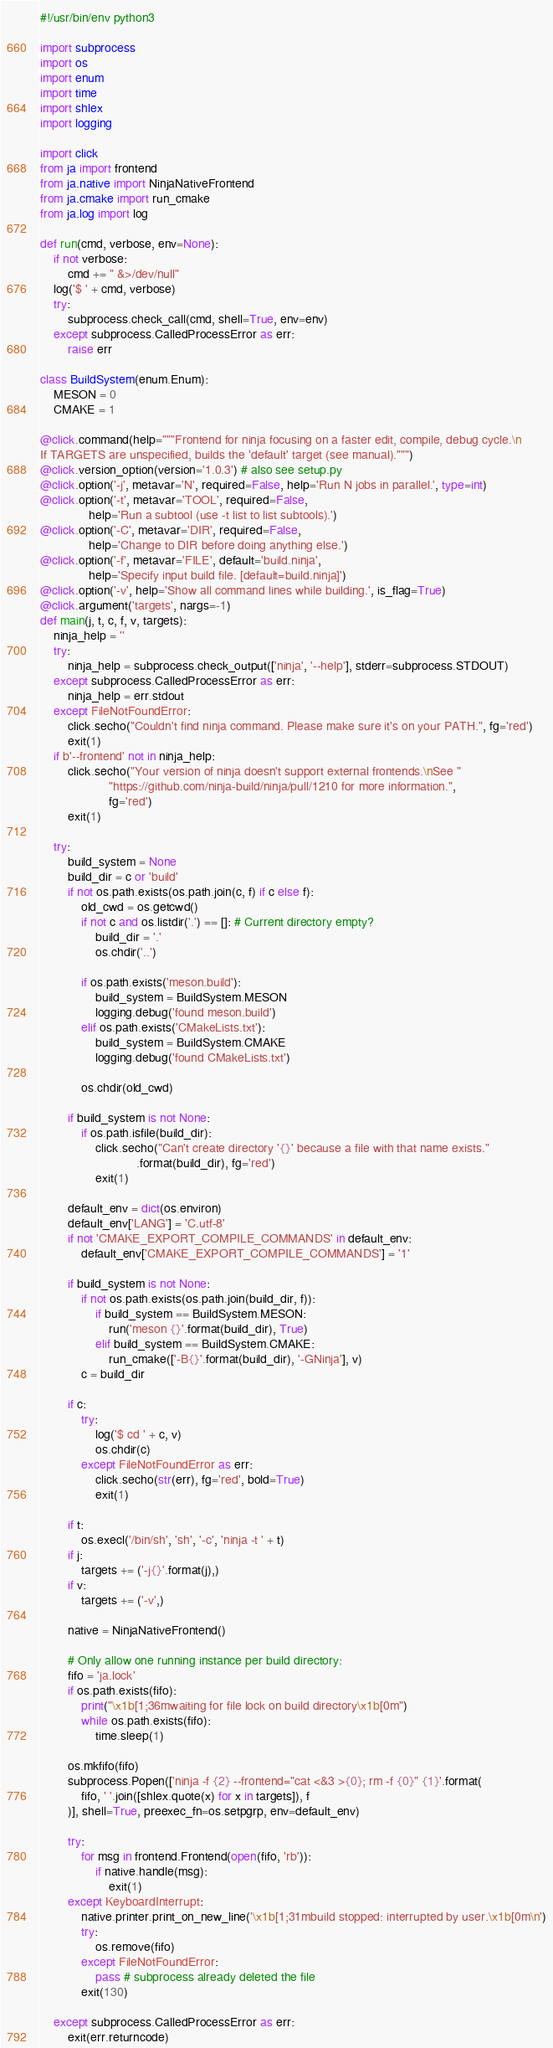Convert code to text. <code><loc_0><loc_0><loc_500><loc_500><_Python_>#!/usr/bin/env python3

import subprocess
import os
import enum
import time
import shlex
import logging

import click
from ja import frontend
from ja.native import NinjaNativeFrontend
from ja.cmake import run_cmake
from ja.log import log

def run(cmd, verbose, env=None):
    if not verbose:
        cmd += " &>/dev/null"
    log('$ ' + cmd, verbose)
    try:
        subprocess.check_call(cmd, shell=True, env=env)
    except subprocess.CalledProcessError as err:
        raise err

class BuildSystem(enum.Enum):
    MESON = 0
    CMAKE = 1

@click.command(help="""Frontend for ninja focusing on a faster edit, compile, debug cycle.\n
If TARGETS are unspecified, builds the 'default' target (see manual).""")
@click.version_option(version='1.0.3') # also see setup.py
@click.option('-j', metavar='N', required=False, help='Run N jobs in parallel.', type=int)
@click.option('-t', metavar='TOOL', required=False,
              help='Run a subtool (use -t list to list subtools).')
@click.option('-C', metavar='DIR', required=False,
              help='Change to DIR before doing anything else.')
@click.option('-f', metavar='FILE', default='build.ninja',
              help='Specify input build file. [default=build.ninja]')
@click.option('-v', help='Show all command lines while building.', is_flag=True)
@click.argument('targets', nargs=-1)
def main(j, t, c, f, v, targets):
    ninja_help = ''
    try:
        ninja_help = subprocess.check_output(['ninja', '--help'], stderr=subprocess.STDOUT)
    except subprocess.CalledProcessError as err:
        ninja_help = err.stdout
    except FileNotFoundError:
        click.secho("Couldn't find ninja command. Please make sure it's on your PATH.", fg='red')
        exit(1)
    if b'--frontend' not in ninja_help:
        click.secho("Your version of ninja doesn't support external frontends.\nSee "
                    "https://github.com/ninja-build/ninja/pull/1210 for more information.",
                    fg='red')
        exit(1)

    try:
        build_system = None
        build_dir = c or 'build'
        if not os.path.exists(os.path.join(c, f) if c else f):
            old_cwd = os.getcwd()
            if not c and os.listdir('.') == []: # Current directory empty?
                build_dir = '.'
                os.chdir('..')

            if os.path.exists('meson.build'):
                build_system = BuildSystem.MESON
                logging.debug('found meson.build')
            elif os.path.exists('CMakeLists.txt'):
                build_system = BuildSystem.CMAKE
                logging.debug('found CMakeLists.txt')

            os.chdir(old_cwd)

        if build_system is not None:
            if os.path.isfile(build_dir):
                click.secho("Can't create directory '{}' because a file with that name exists."
                            .format(build_dir), fg='red')
                exit(1)

        default_env = dict(os.environ)
        default_env['LANG'] = 'C.utf-8'
        if not 'CMAKE_EXPORT_COMPILE_COMMANDS' in default_env:
            default_env['CMAKE_EXPORT_COMPILE_COMMANDS'] = '1'

        if build_system is not None:
            if not os.path.exists(os.path.join(build_dir, f)):
                if build_system == BuildSystem.MESON:
                    run('meson {}'.format(build_dir), True)
                elif build_system == BuildSystem.CMAKE:
                    run_cmake(['-B{}'.format(build_dir), '-GNinja'], v)
            c = build_dir

        if c:
            try:
                log('$ cd ' + c, v)
                os.chdir(c)
            except FileNotFoundError as err:
                click.secho(str(err), fg='red', bold=True)
                exit(1)

        if t:
            os.execl('/bin/sh', 'sh', '-c', 'ninja -t ' + t)
        if j:
            targets += ('-j{}'.format(j),)
        if v:
            targets += ('-v',)

        native = NinjaNativeFrontend()

        # Only allow one running instance per build directory:
        fifo = 'ja.lock'
        if os.path.exists(fifo):
            print("\x1b[1;36mwaiting for file lock on build directory\x1b[0m")
            while os.path.exists(fifo):
                time.sleep(1)

        os.mkfifo(fifo)
        subprocess.Popen(['ninja -f {2} --frontend="cat <&3 >{0}; rm -f {0}" {1}'.format(
            fifo, ' '.join([shlex.quote(x) for x in targets]), f
        )], shell=True, preexec_fn=os.setpgrp, env=default_env)

        try:
            for msg in frontend.Frontend(open(fifo, 'rb')):
                if native.handle(msg):
                    exit(1)
        except KeyboardInterrupt:
            native.printer.print_on_new_line('\x1b[1;31mbuild stopped: interrupted by user.\x1b[0m\n')
            try:
                os.remove(fifo)
            except FileNotFoundError:
                pass # subprocess already deleted the file
            exit(130)

    except subprocess.CalledProcessError as err:
        exit(err.returncode)
</code> 